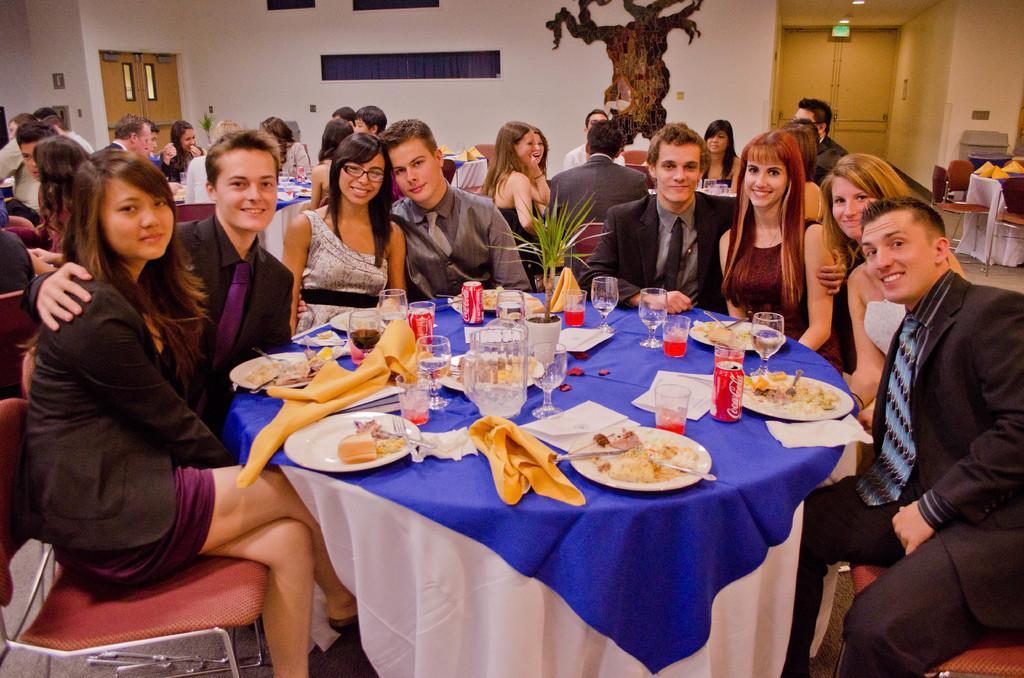Please provide a concise description of this image. Group of people are sat on the red color chair. Here we can see so many tables. There are few items are placed on it. Here and here. The back side, we can see white color wall cream color doors. Here there is a painting. There is a sign here. 